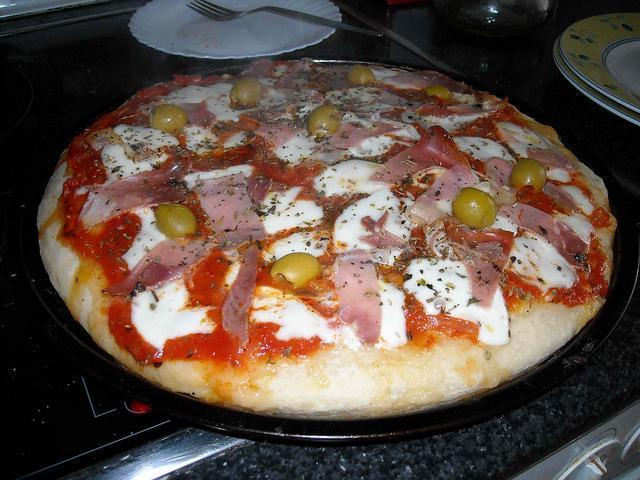How many plates are visible in the picture?
Give a very brief answer. 3. How many pizzas are there?
Give a very brief answer. 1. How many giraffes are in the photo?
Give a very brief answer. 0. 